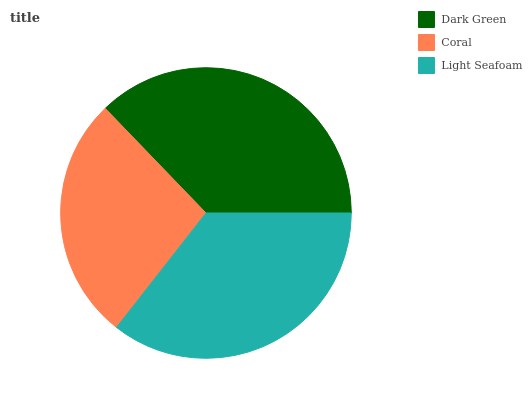Is Coral the minimum?
Answer yes or no. Yes. Is Dark Green the maximum?
Answer yes or no. Yes. Is Light Seafoam the minimum?
Answer yes or no. No. Is Light Seafoam the maximum?
Answer yes or no. No. Is Light Seafoam greater than Coral?
Answer yes or no. Yes. Is Coral less than Light Seafoam?
Answer yes or no. Yes. Is Coral greater than Light Seafoam?
Answer yes or no. No. Is Light Seafoam less than Coral?
Answer yes or no. No. Is Light Seafoam the high median?
Answer yes or no. Yes. Is Light Seafoam the low median?
Answer yes or no. Yes. Is Dark Green the high median?
Answer yes or no. No. Is Coral the low median?
Answer yes or no. No. 